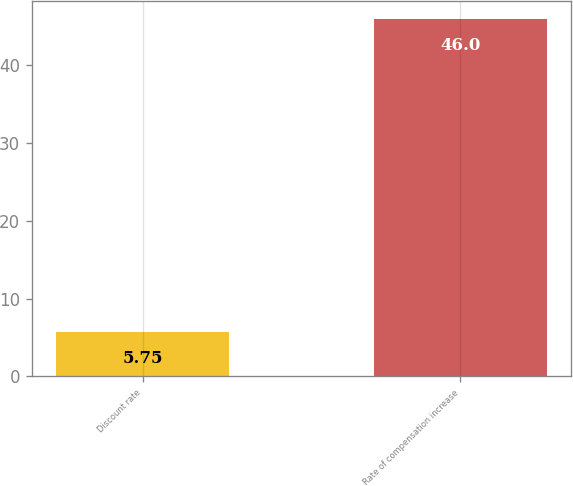Convert chart. <chart><loc_0><loc_0><loc_500><loc_500><bar_chart><fcel>Discount rate<fcel>Rate of compensation increase<nl><fcel>5.75<fcel>46<nl></chart> 